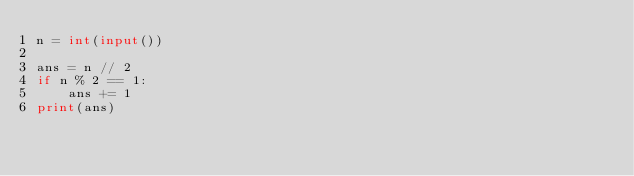<code> <loc_0><loc_0><loc_500><loc_500><_Python_>n = int(input())

ans = n // 2
if n % 2 == 1:
    ans += 1
print(ans)
</code> 